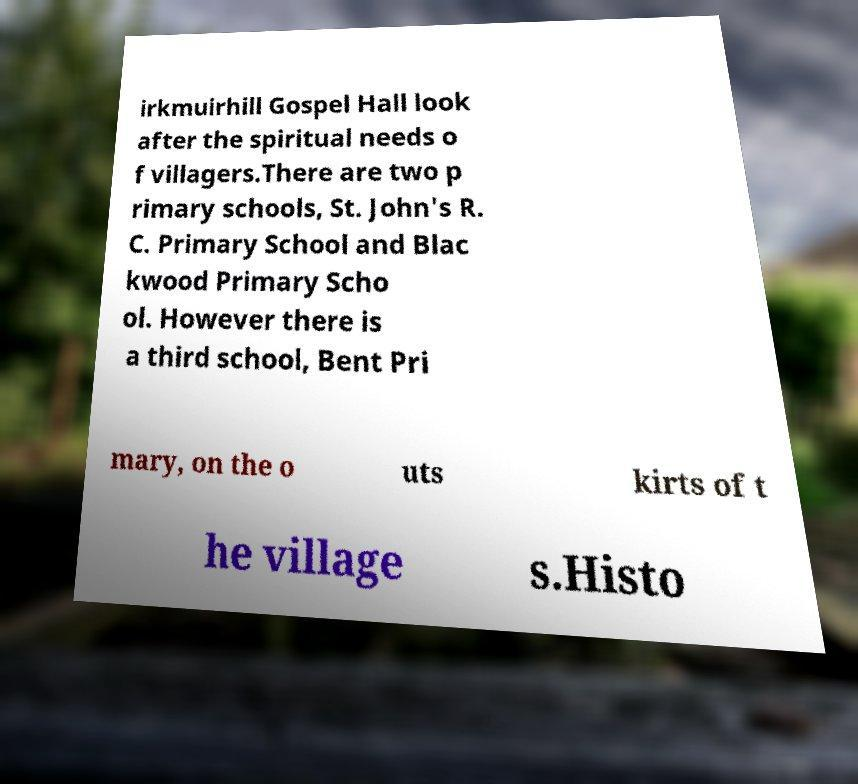Can you accurately transcribe the text from the provided image for me? irkmuirhill Gospel Hall look after the spiritual needs o f villagers.There are two p rimary schools, St. John's R. C. Primary School and Blac kwood Primary Scho ol. However there is a third school, Bent Pri mary, on the o uts kirts of t he village s.Histo 